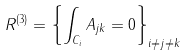<formula> <loc_0><loc_0><loc_500><loc_500>R ^ { ( 3 ) } = \left \{ \int _ { C _ { i } } A _ { j k } = 0 \right \} _ { i \not = j \not = k }</formula> 